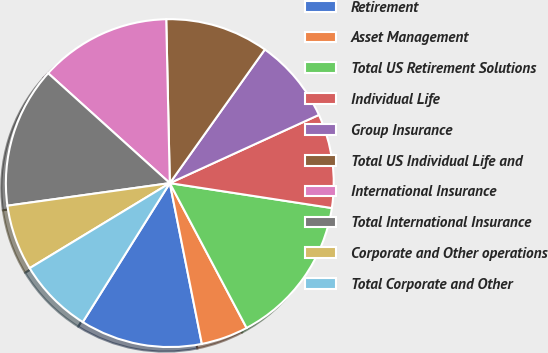<chart> <loc_0><loc_0><loc_500><loc_500><pie_chart><fcel>Retirement<fcel>Asset Management<fcel>Total US Retirement Solutions<fcel>Individual Life<fcel>Group Insurance<fcel>Total US Individual Life and<fcel>International Insurance<fcel>Total International Insurance<fcel>Corporate and Other operations<fcel>Total Corporate and Other<nl><fcel>12.04%<fcel>4.63%<fcel>14.81%<fcel>9.26%<fcel>8.33%<fcel>10.19%<fcel>12.96%<fcel>13.89%<fcel>6.48%<fcel>7.41%<nl></chart> 